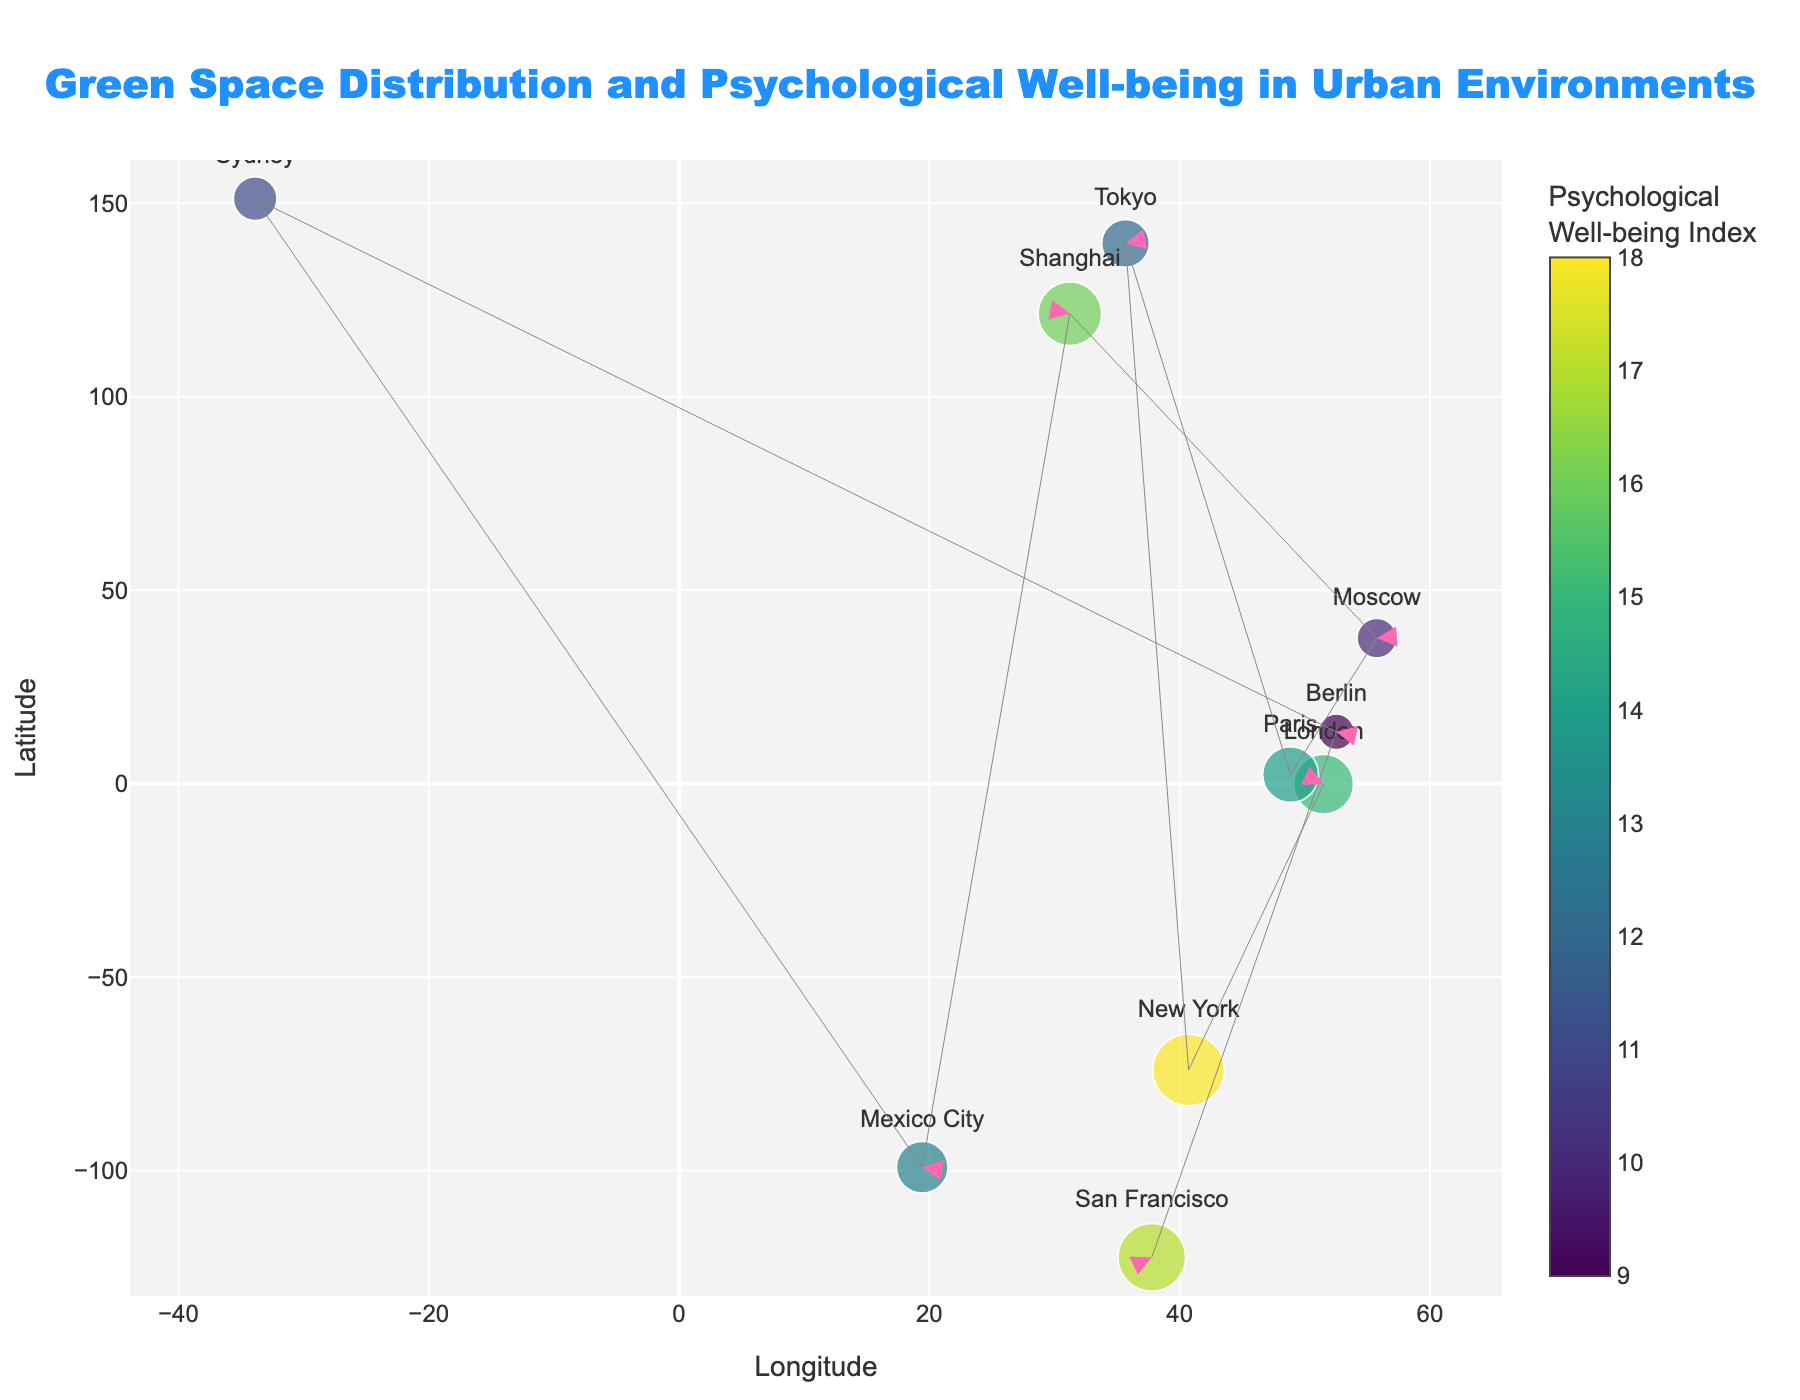What is the title of the figure? The title is usually displayed at the top of the plot and can be read directly.
Answer: Green Space Distribution and Psychological Well-being in Urban Environments Which city is represented by the largest marker? The marker size corresponds to the 'size' attribute in the data. By looking for the largest marker, we find it's for New York with a size of 18.
Answer: New York Which city has the smallest marker? The marker size corresponds to the 'size' attribute in the plot. The smallest marker on the plot is for Berlin, which has a size of 9.
Answer: Berlin What is the color scale used in the plot? The color scale is referred to as 'Viridis' in the instructions, which is generally a gradient from dark purple to yellow.
Answer: Viridis Which city has the highest latitude value? By checking the y-axis (latitude) values, the highest latitude is for Moscow at 55.7558.
Answer: Moscow What direction does the arrow for Tokyo point to? The arrow direction is determined by the (u, v) components. For Tokyo, u = 0.3 and v = 0.2, pointing to the right and slightly up.
Answer: Right and slightly upward What is the average psychological well-being index of all cities combined? Sum the size values and divide by the number of cities: (15 + 18 + 12 + 14 + 10 + 16 + 13 + 11 + 9 + 17) / 10 = 13.5
Answer: 13.5 Which city has the most positive change in green space indicated by the arrows? Positive change is indicated by the highest values in (u, v). Moscow (u=0.4, v=0.1) indicates the most positive change.
Answer: Moscow What is the total sum of u-components for all cities? Sum the u-components: (-0.2 + 0.1 + 0.3 - 0.1 + 0.4 - 0.3 + 0.2 - 0.1 + 0.3 - 0.2) = 0.4
Answer: 0.4 Which cities have a downward trend in green space? A downward trend is indicated by a negative v-component. Cities with negative v-components are New York, Paris, Mexico City, Berlin, and San Francisco.
Answer: New York, Paris, Mexico City, Berlin, San Francisco 